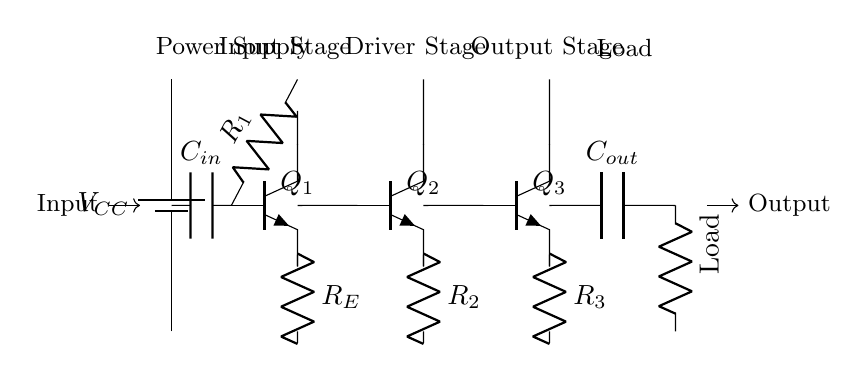What is the type of transistor used in the input stage? The input stage uses a BJT transistor, specifically labeled as Q1 on the diagram. This is indicated by the symbol and the labeling present.
Answer: BJT What is the role of the capacitor labeled C_in? C_in is a coupling capacitor that allows AC signals to pass while blocking DC components, as indicated by its position isolating the input from the base of the transistor Q1.
Answer: Coupling What is the load connected to this amplifier circuit? The load is represented by a resistor labeled as "Load," which is the final element in the circuit before the output.
Answer: Resistor Which stage of the amplifier provides the highest voltage gain? The driver stage, which uses transistor Q2, typically provides significant voltage gain due to its position in the amplification process and connection to both the input and output stages.
Answer: Driver stage What is the purpose of the resistor labeled R_E? R_E serves as an emitter resistor that stabilizes the emitter current by providing negative feedback, which is crucial for maintaining consistent transistor operation.
Answer: Stabilization What happens to the signal as it passes through C_out? C_out acts as an output coupling capacitor, allowing the amplified AC signal to reach the load while blocking any DC offset that might be present.
Answer: Signal transmission 